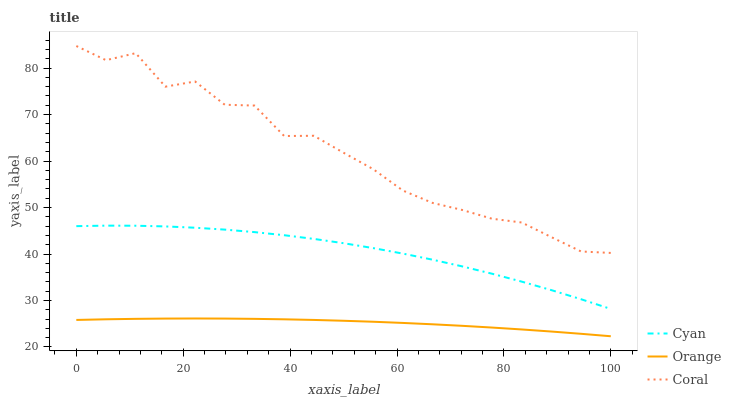Does Orange have the minimum area under the curve?
Answer yes or no. Yes. Does Coral have the maximum area under the curve?
Answer yes or no. Yes. Does Cyan have the minimum area under the curve?
Answer yes or no. No. Does Cyan have the maximum area under the curve?
Answer yes or no. No. Is Orange the smoothest?
Answer yes or no. Yes. Is Coral the roughest?
Answer yes or no. Yes. Is Cyan the smoothest?
Answer yes or no. No. Is Cyan the roughest?
Answer yes or no. No. Does Orange have the lowest value?
Answer yes or no. Yes. Does Cyan have the lowest value?
Answer yes or no. No. Does Coral have the highest value?
Answer yes or no. Yes. Does Cyan have the highest value?
Answer yes or no. No. Is Cyan less than Coral?
Answer yes or no. Yes. Is Coral greater than Orange?
Answer yes or no. Yes. Does Cyan intersect Coral?
Answer yes or no. No. 